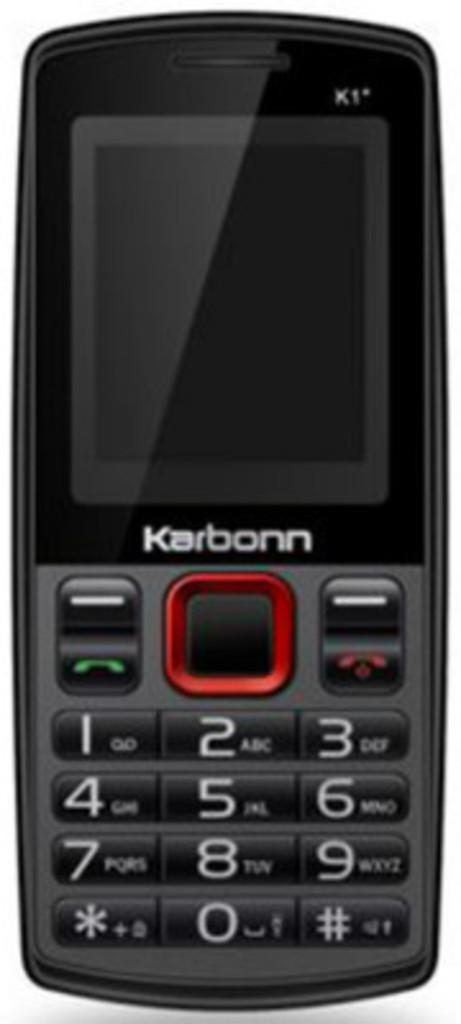<image>
Describe the image concisely. A small black cellaphone by the brand Karbonn. 